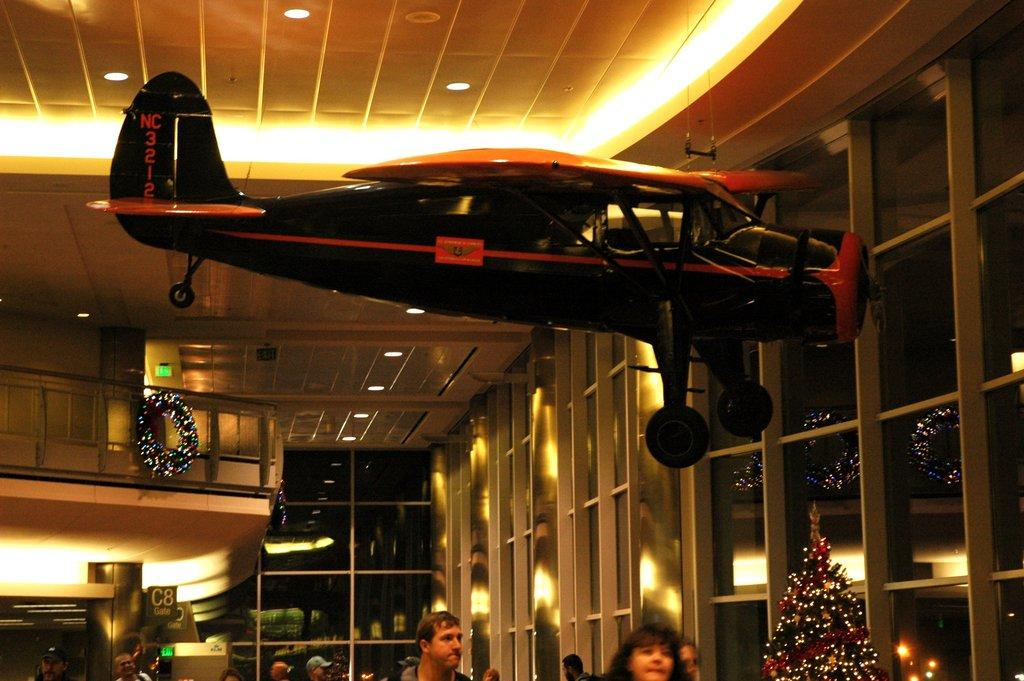What type of aircraft is depicted in the image? There is an artificial aircraft in the image. Can you describe the lighting in the image? There are lights in the image. What kind of structure can be seen in the image? There is a railing in the image. What type of objects are present for decoration? There are decorative objects in the image. What type of storage or display furniture is present in the image? There are wooden racks in the image. Are there any people visible in the image? Yes, there are people standing in the image. What type of gun can be seen in the hands of the people in the image? There is no gun present in the image; the people are not holding any weapons. What type of rhythm can be heard in the background of the image? There is no sound or music present in the image, so it is not possible to determine the rhythm. 